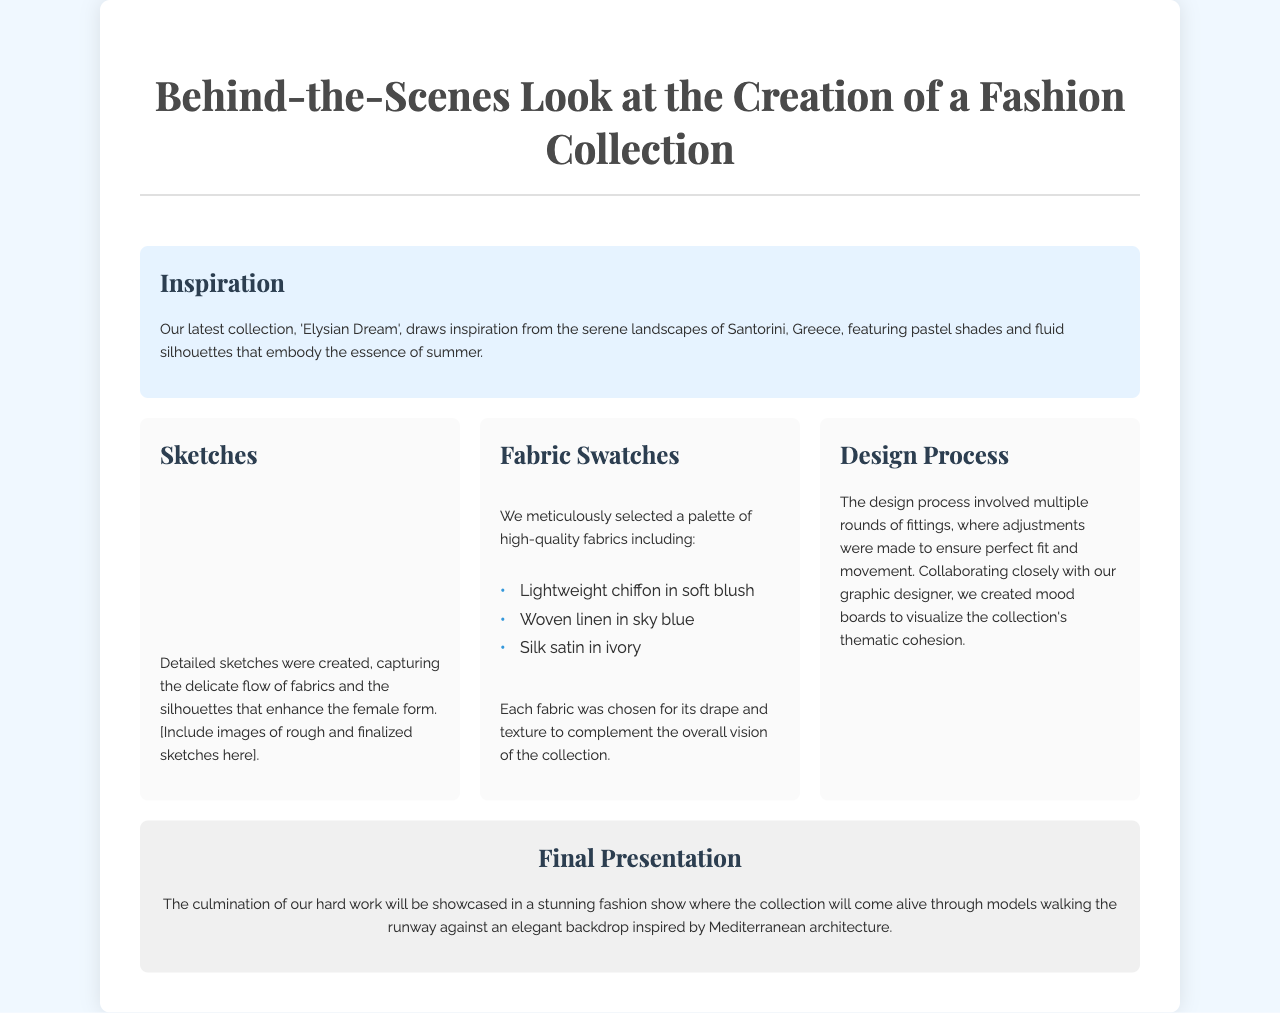What is the name of the collection? The name of the collection is stated in the title of the brochure.
Answer: Elysian Dream What are the three fabric types mentioned? The document lists specific fabric types in the Fabric Swatches section.
Answer: Chiffon, linen, satin Which location inspired the collection? The inspiration section specifies the geographic location influencing the design.
Answer: Santorini, Greece What color is the chiffon fabric? The specific color of the chiffon fabric is mentioned in the list of fabrics.
Answer: Soft blush How did the design process ensure a perfect fit? The explanation in the design process section highlights what was done to achieve the fit.
Answer: Multiple rounds of fittings What design element did the graphic designer help create? The design process section refers to a specific visual representation created with the graphic designer's collaboration.
Answer: Mood boards What type of presentation is planned for the collection? The final presentation section describes how the collection will be showcased.
Answer: Fashion show What backdrop will be used in the fashion show? The document mentions an element that will enhance the runway experience.
Answer: Mediterranean architecture 